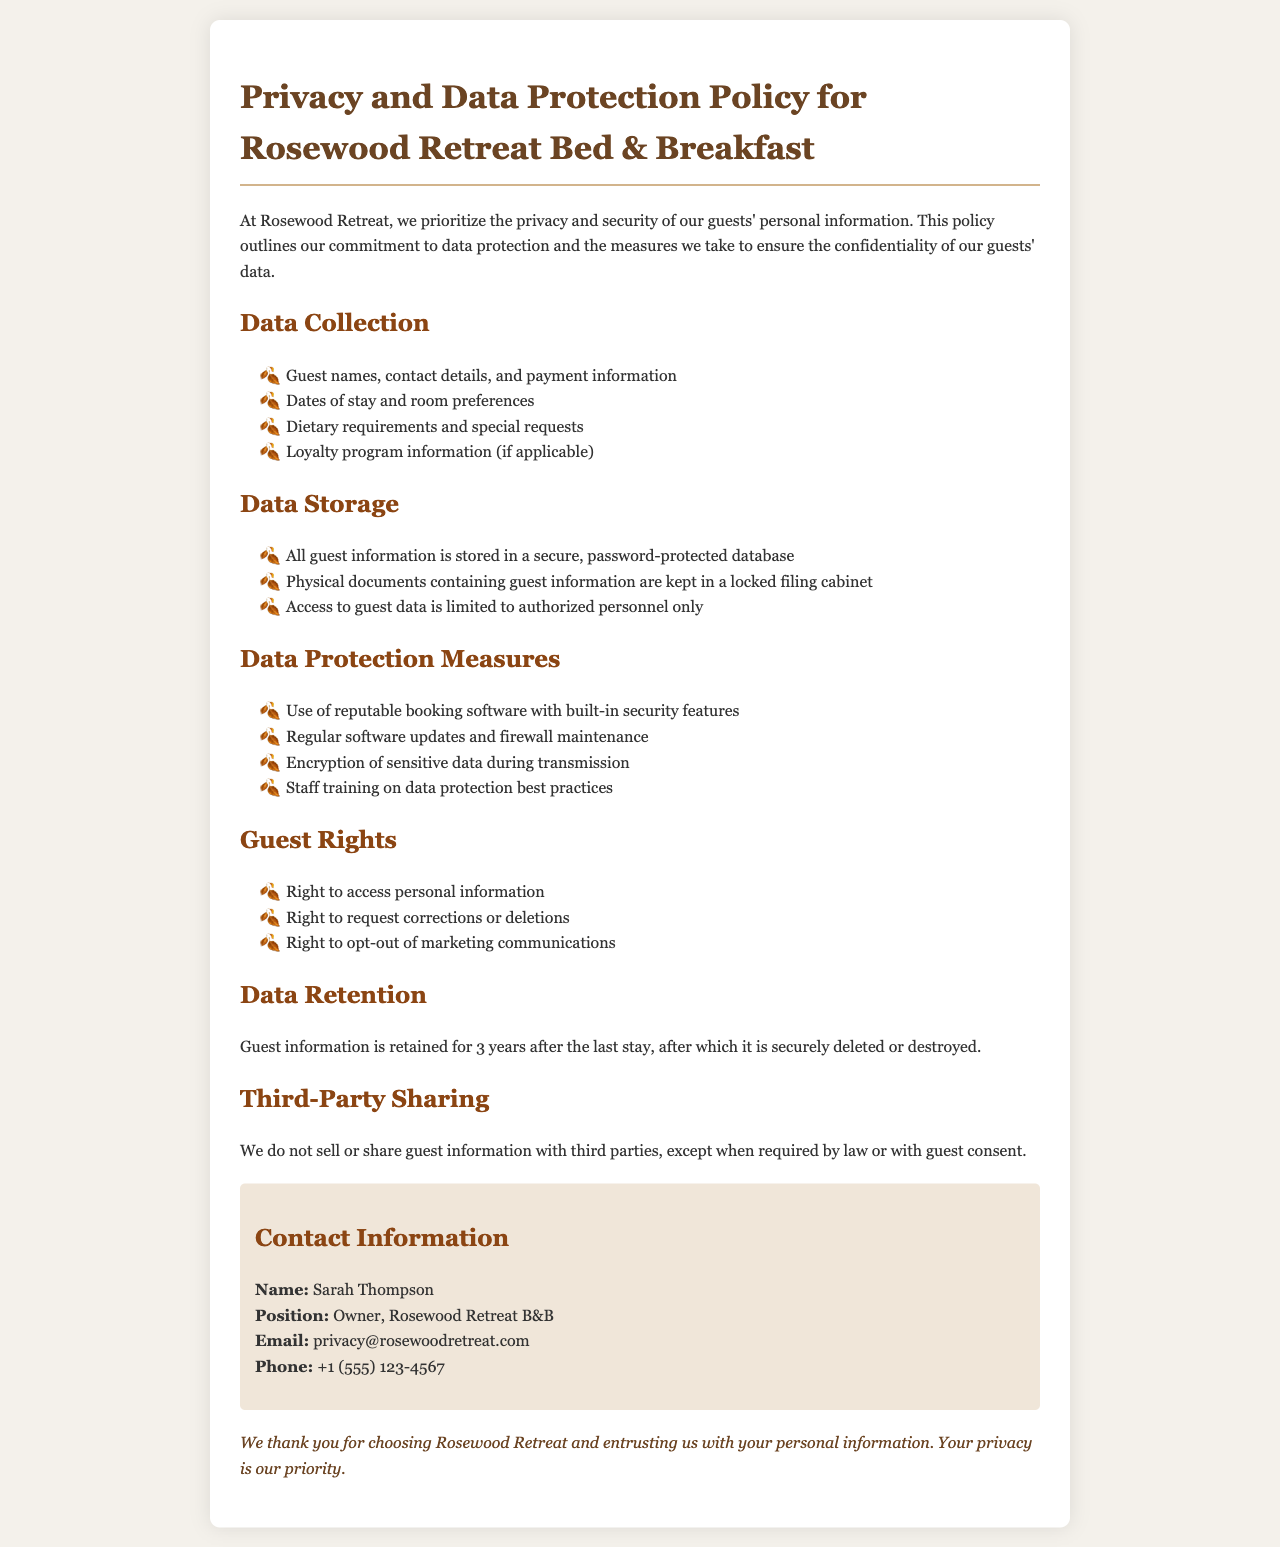What types of guest information are collected? The document lists the types of information collected, such as guest names, contact details, and payment information.
Answer: Guest names, contact details, and payment information How long is guest information retained? The policy specifies the duration for which guest data is retained after the last stay.
Answer: 3 years What is the contact email for privacy inquiries? The document provides the contact email for guests with questions about privacy.
Answer: privacy@rosewoodretreat.com Who is the owner of Rosewood Retreat B&B? The document states the name of the person in charge of the B&B.
Answer: Sarah Thompson What security measure involves regular updates? One of the data protection measures mentioned is related to maintaining the software.
Answer: Regular software updates What right allows guests to opt-out of communications? The document outlines the guests' rights, including the ability to refuse certain communications.
Answer: Right to opt-out of marketing communications Where is physical guest information stored? The policy describes the storage location for physical documents containing guest data.
Answer: Locked filing cabinet Are third parties allowed access to guest information? The document explains the conditions under which guest data may be shared with external parties.
Answer: No, except when required by law or with guest consent 